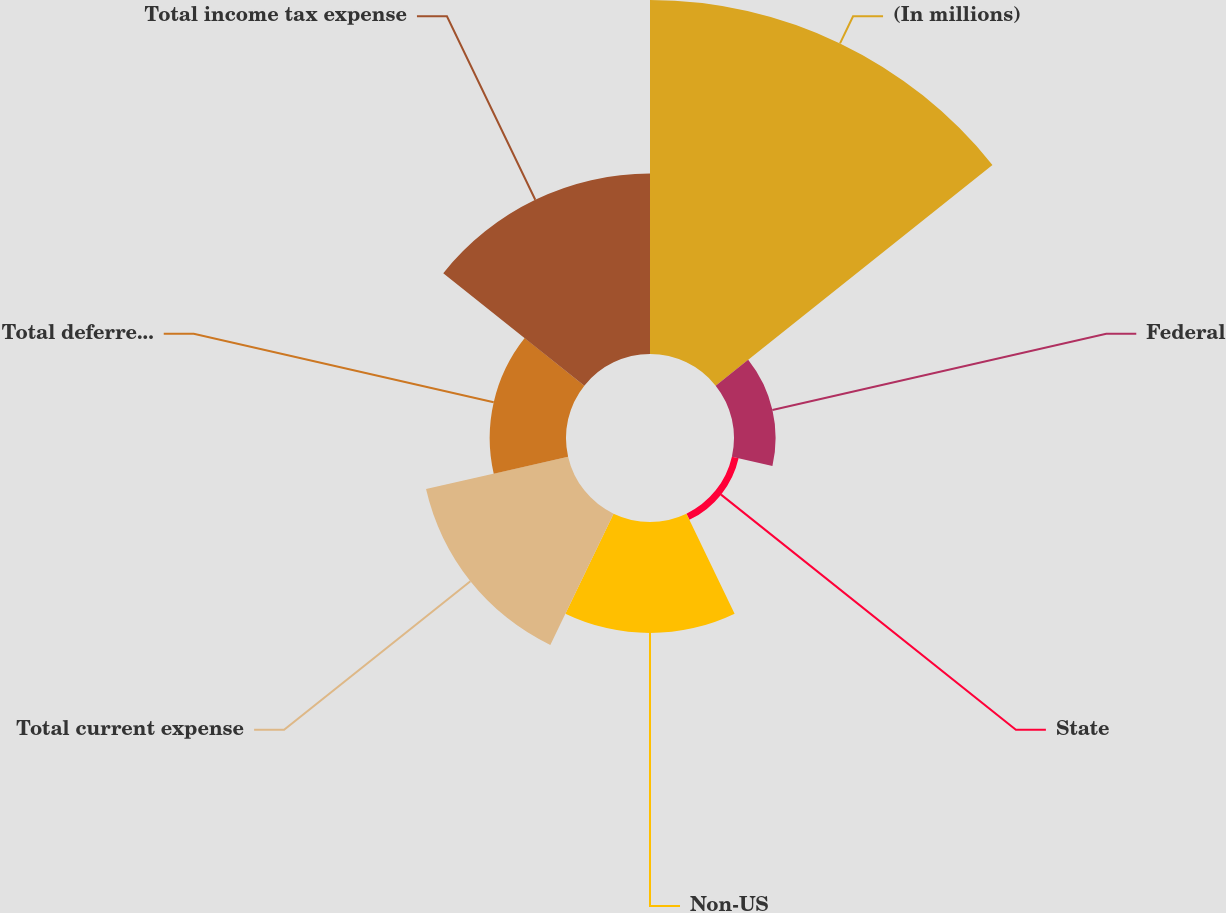<chart> <loc_0><loc_0><loc_500><loc_500><pie_chart><fcel>(In millions)<fcel>Federal<fcel>State<fcel>Non-US<fcel>Total current expense<fcel>Total deferred expense<fcel>Total income tax expense<nl><fcel>38.65%<fcel>4.54%<fcel>0.75%<fcel>12.12%<fcel>15.91%<fcel>8.33%<fcel>19.7%<nl></chart> 